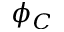<formula> <loc_0><loc_0><loc_500><loc_500>\phi _ { C }</formula> 